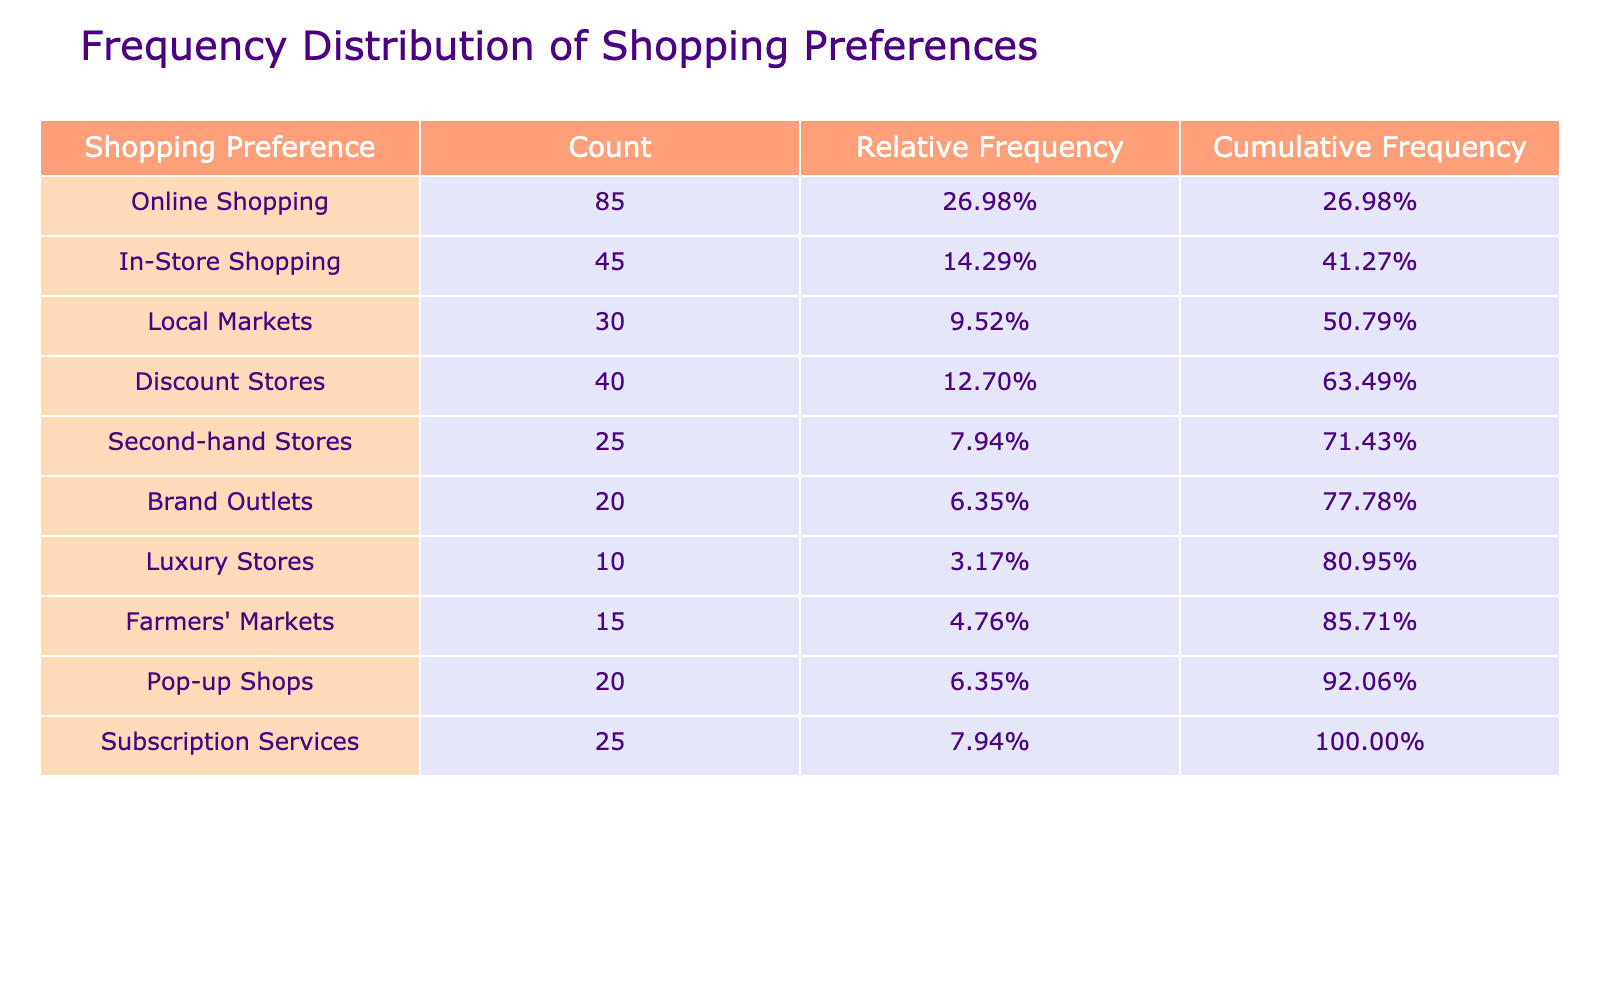What is the total number of respondents? To find the total number of respondents, we sum up the counts for all shopping preferences: 85 + 45 + 30 + 40 + 25 + 20 + 10 + 15 + 20 + 25 =  345.
Answer: 345 Which shopping preference received the highest count? Looking at the 'Count' column, the highest value is 85, which corresponds to 'Online Shopping'.
Answer: Online Shopping What percentage of respondents prefer In-Store Shopping? The count for In-Store Shopping is 45. To find the percentage, divide 45 by the total count (345), then multiply by 100. (45/345) * 100 ≈ 13.04%.
Answer: Approximately 13.04% Is the preference for Luxury Stores more than double that for Second-hand Stores? The count for Luxury Stores is 10 and for Second-hand Stores is 25. Double of Second-hand Stores would be 2 * 25 = 50. Since 10 is less than 50, the statement is false.
Answer: No What is the cumulative frequency of Subscription Services? To find the cumulative frequency of Subscription Services, we need to calculate the total frequency up to that point. The counts before it are Online Shopping (85), In-Store Shopping (45), Local Markets (30), Discount Stores (40), and Second-hand Stores (25). Adding these gives 85 + 45 + 30 + 40 + 25 = 225. Now adding Subscription Services (25) gives 225 + 25 = 250. The cumulative frequency is 250.
Answer: 250 What is the difference in count between the most popular and least popular shopping preference? The most popular shopping preference is Online Shopping (85) and the least popular is Luxury Stores (10). The difference is 85 - 10 = 75.
Answer: 75 What is the relative frequency of Local Markets? The count for Local Markets is 30. To find relative frequency, divide by the total number (345). (30/345) ≈ 0.087, which is approximately 8.70% when converted to a percentage.
Answer: Approximately 8.70% Among the options provided, which category do more than 20% of responders prefer? The relative frequency of each category is examined; Online Shopping has 85/345 = 24.64%. This is more than 20%. (No other category exceeds this threshold).
Answer: Online Shopping Which shopping preference categories have counts less than or equal to 25? The categories with counts less than or equal to 25 are Second-hand Stores (25), Brand Outlets (20), Luxury Stores (10), and Farmers' Markets (15).
Answer: Second-hand Stores, Brand Outlets, Luxury Stores, Farmers' Markets 